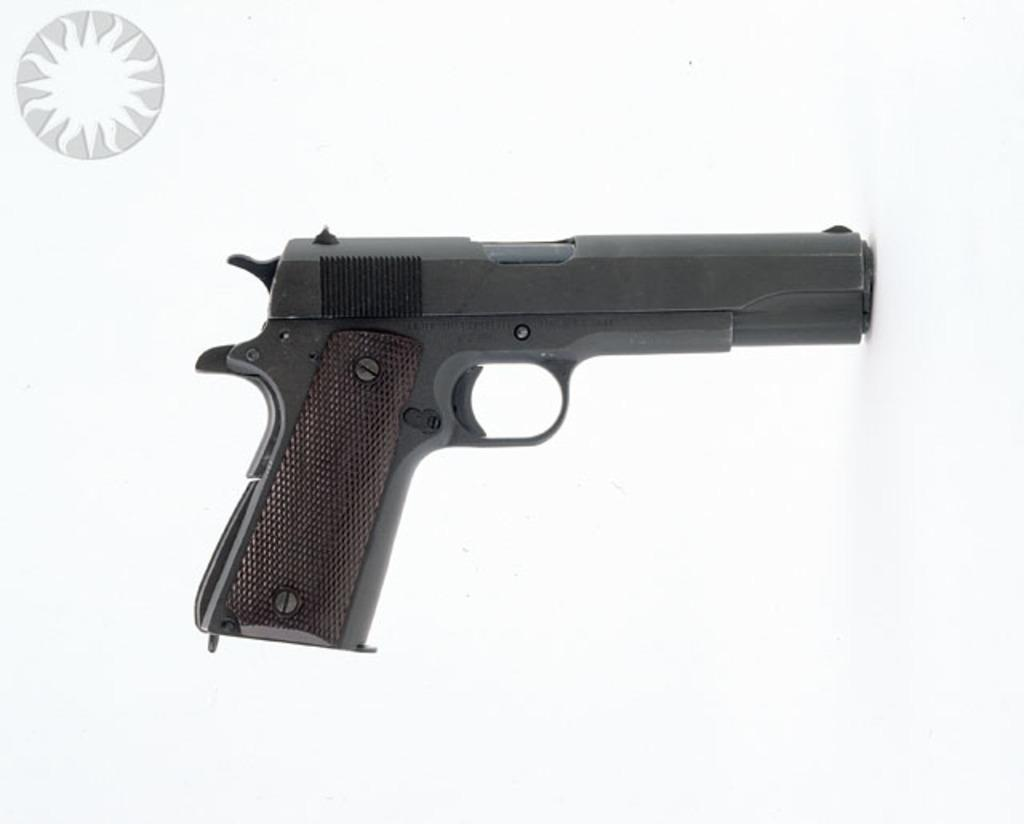What is the main object in the picture? There is a gun in the picture. Is there any text or symbol in the picture? Yes, there appears to be a logo in the top left corner of the picture. What color is the background of the image? The background of the image is white. How many pencils are visible in the picture? There are no pencils visible in the picture. What type of market is depicted in the image? There is no market depicted in the image. 